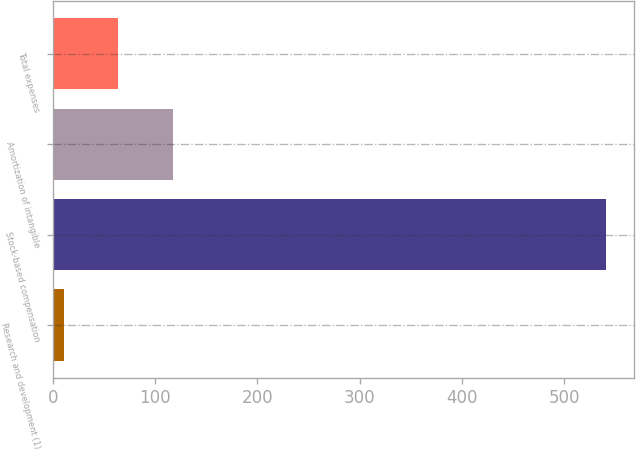<chart> <loc_0><loc_0><loc_500><loc_500><bar_chart><fcel>Research and development (1)<fcel>Stock-based compensation<fcel>Amortization of intangible<fcel>Total expenses<nl><fcel>11<fcel>541<fcel>117<fcel>64<nl></chart> 